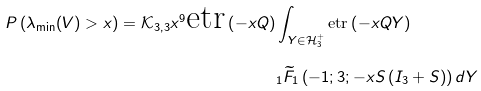Convert formula to latex. <formula><loc_0><loc_0><loc_500><loc_500>P \left ( \lambda _ { \min } ( V ) > x \right ) = \mathcal { K } _ { 3 , 3 } x ^ { 9 } \text {etr} \left ( - x Q \right ) & \int _ { Y \in \mathcal { H } _ { 3 } ^ { + } } \text {etr} \left ( - x Q Y \right ) \\ & _ { 1 } \widetilde { F } _ { 1 } \left ( - 1 ; 3 ; - x S \left ( I _ { 3 } + S \right ) \right ) d Y</formula> 